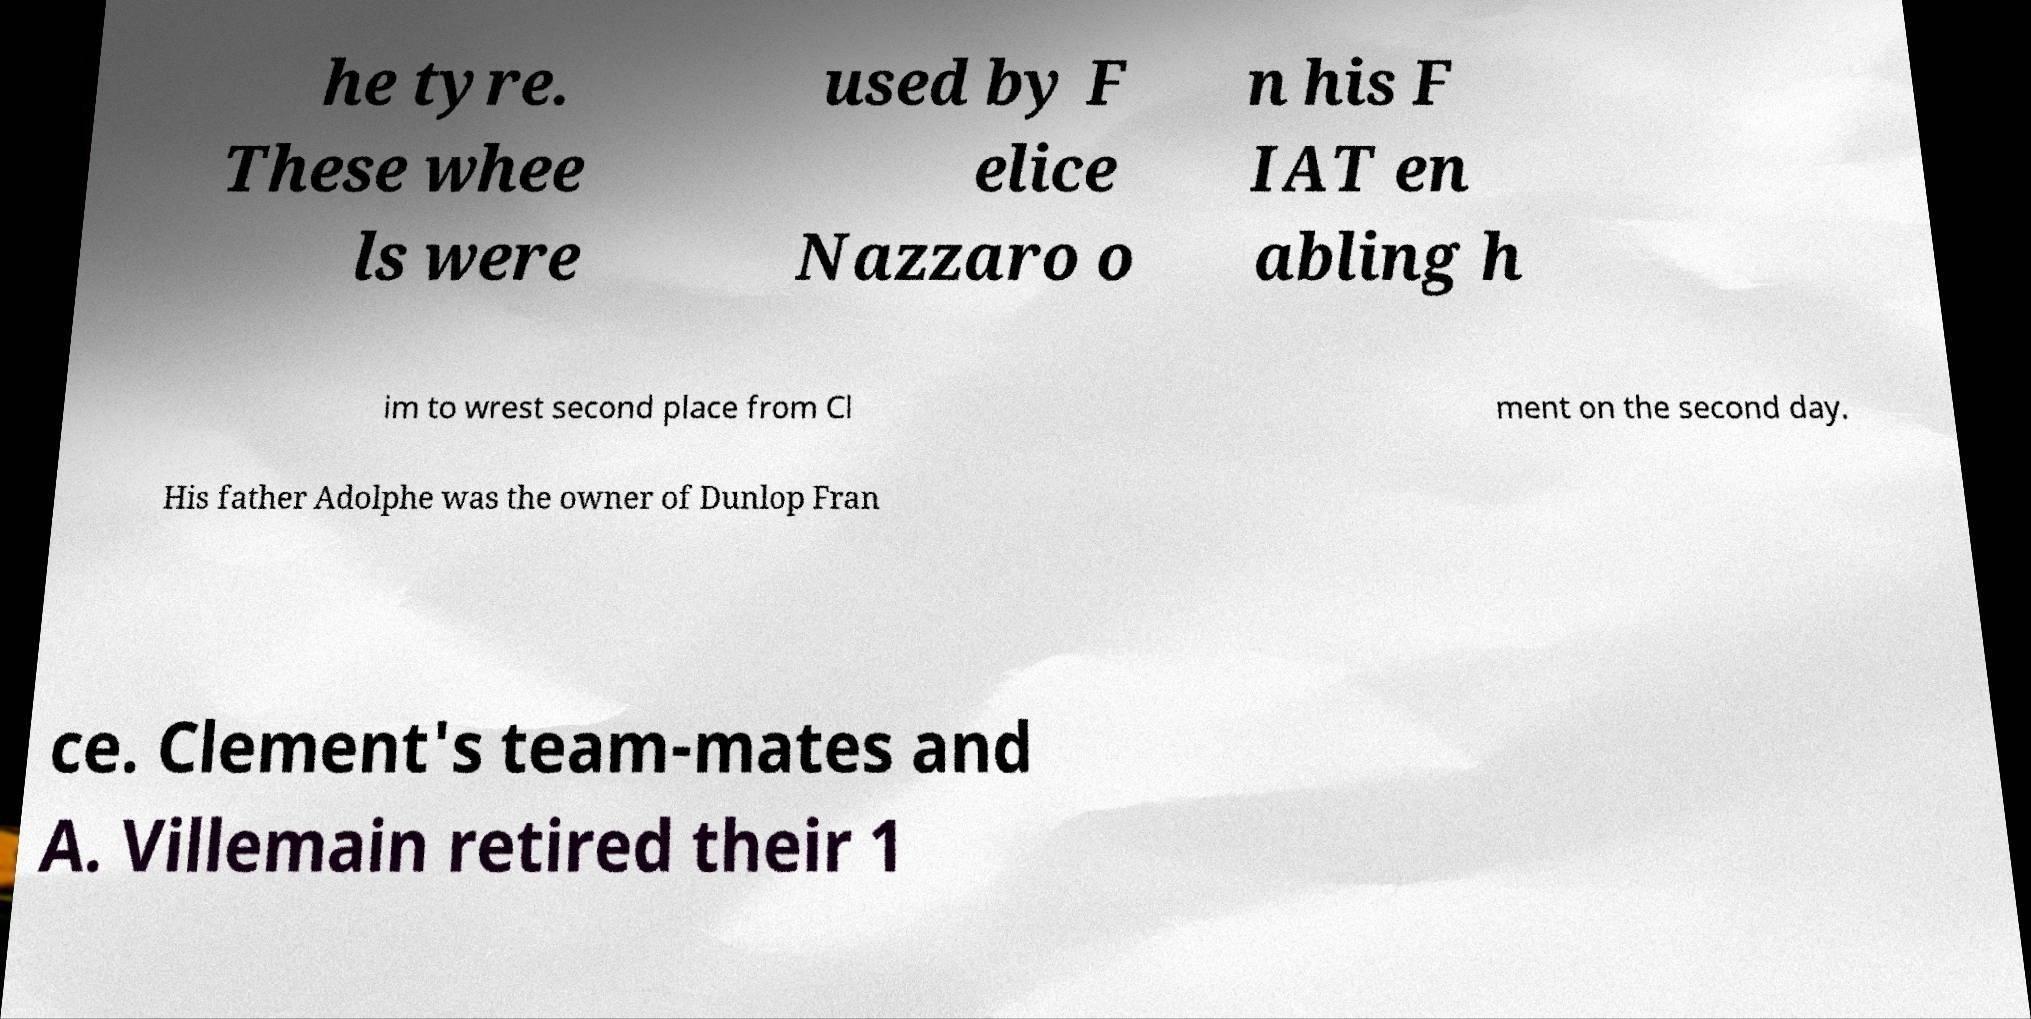I need the written content from this picture converted into text. Can you do that? he tyre. These whee ls were used by F elice Nazzaro o n his F IAT en abling h im to wrest second place from Cl ment on the second day. His father Adolphe was the owner of Dunlop Fran ce. Clement's team-mates and A. Villemain retired their 1 